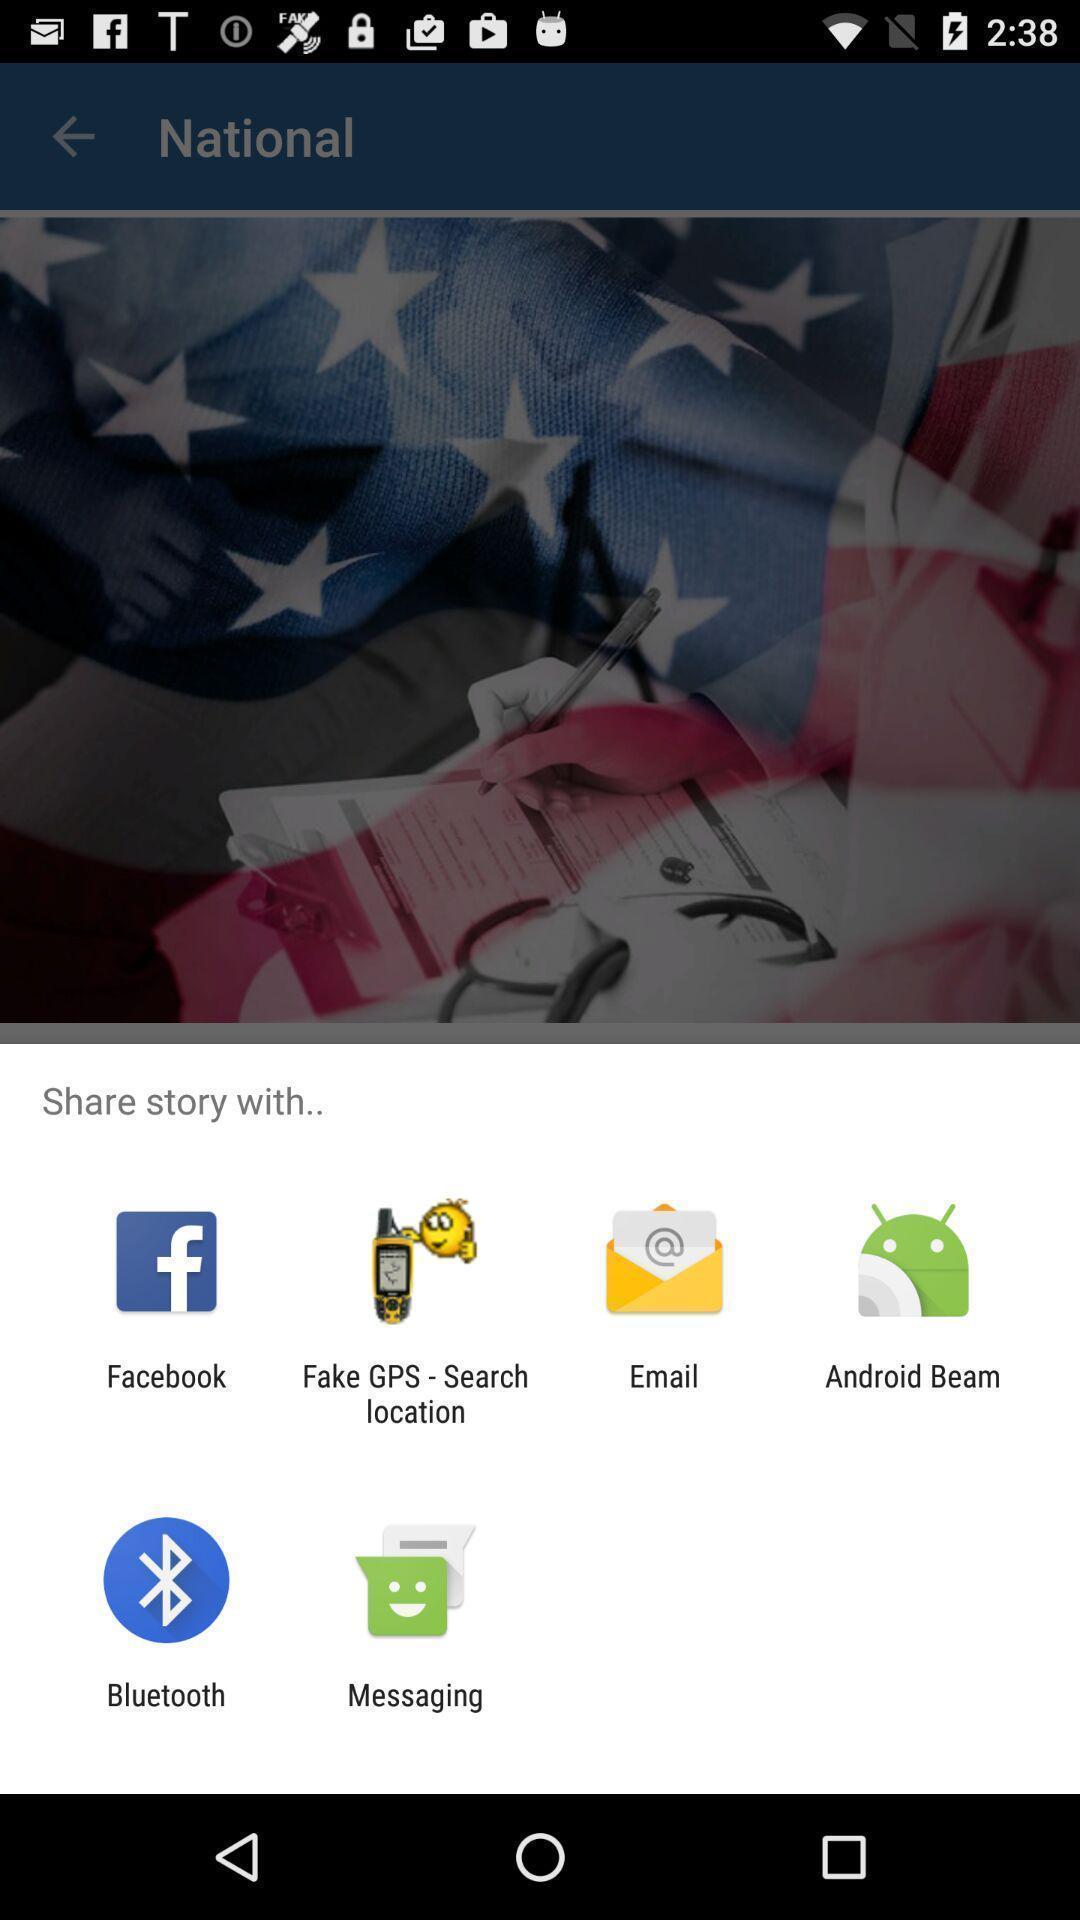Give me a narrative description of this picture. Screen shows number of applications to share. 